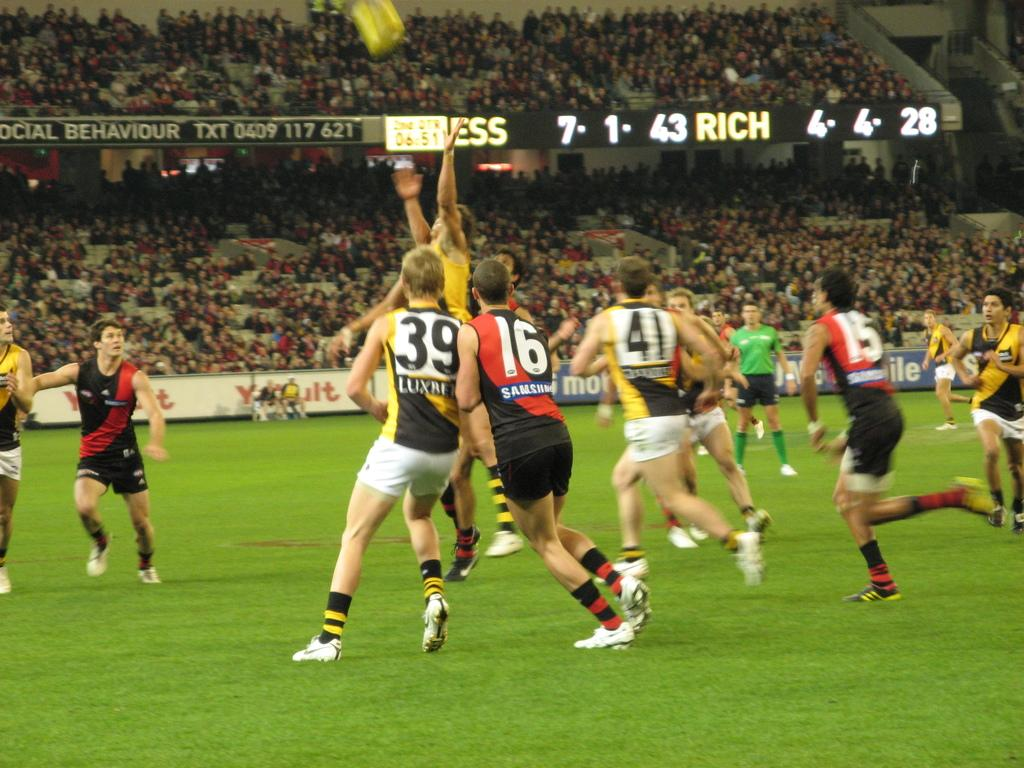<image>
Provide a brief description of the given image. Players number 39 and 16 are touching shoulders. 